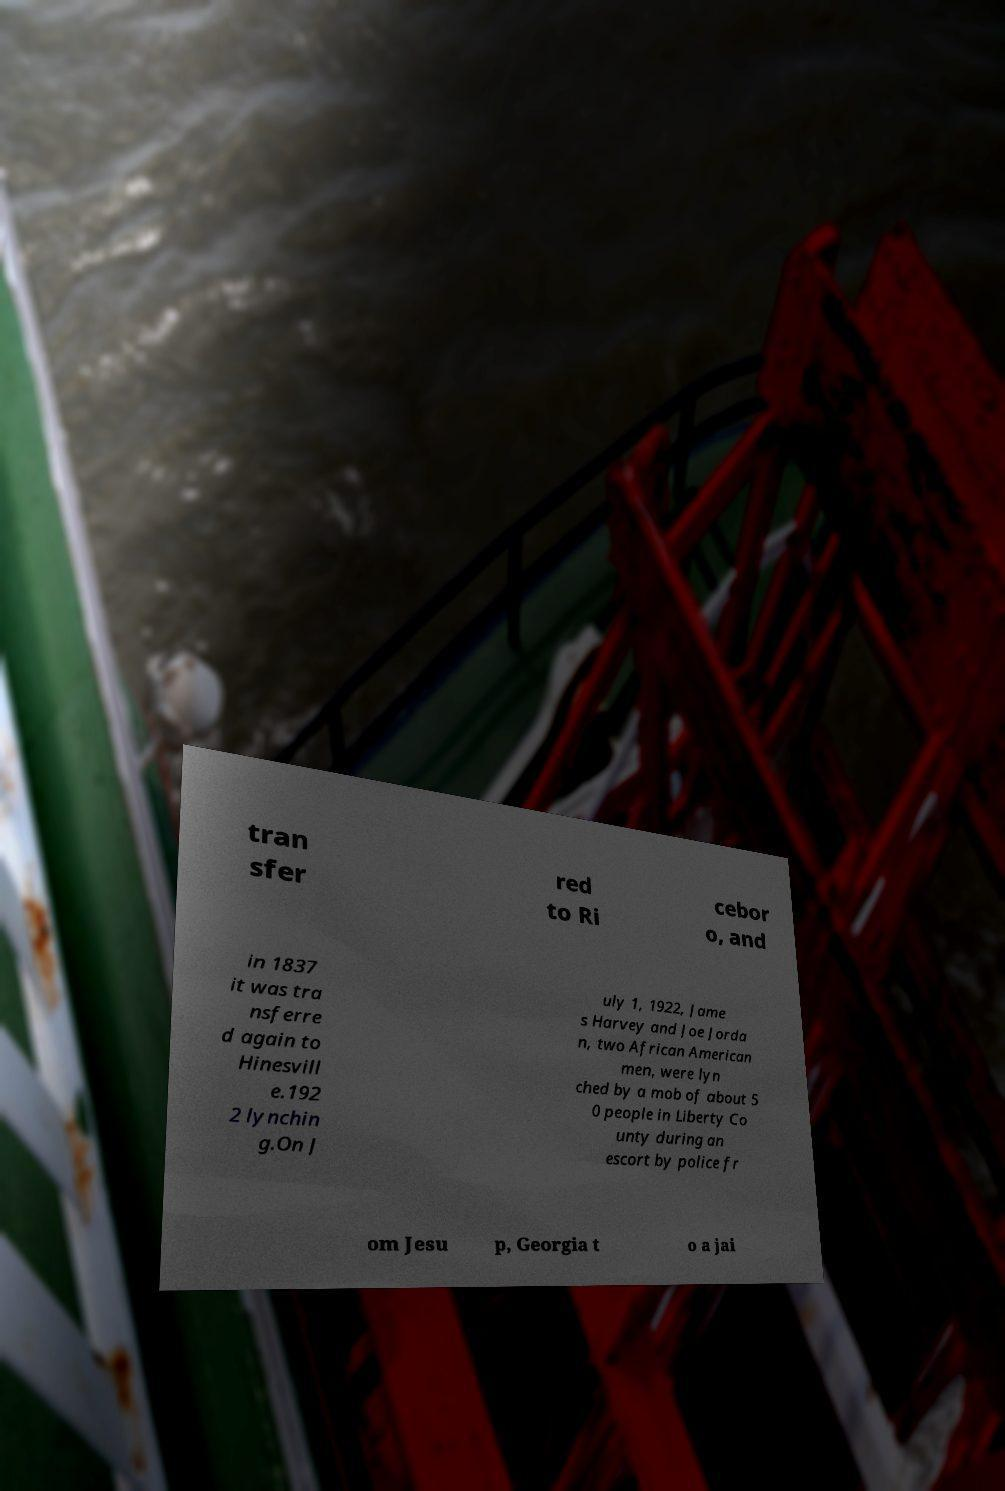I need the written content from this picture converted into text. Can you do that? tran sfer red to Ri cebor o, and in 1837 it was tra nsferre d again to Hinesvill e.192 2 lynchin g.On J uly 1, 1922, Jame s Harvey and Joe Jorda n, two African American men, were lyn ched by a mob of about 5 0 people in Liberty Co unty during an escort by police fr om Jesu p, Georgia t o a jai 